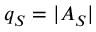Convert formula to latex. <formula><loc_0><loc_0><loc_500><loc_500>q _ { S } = | A _ { S } |</formula> 